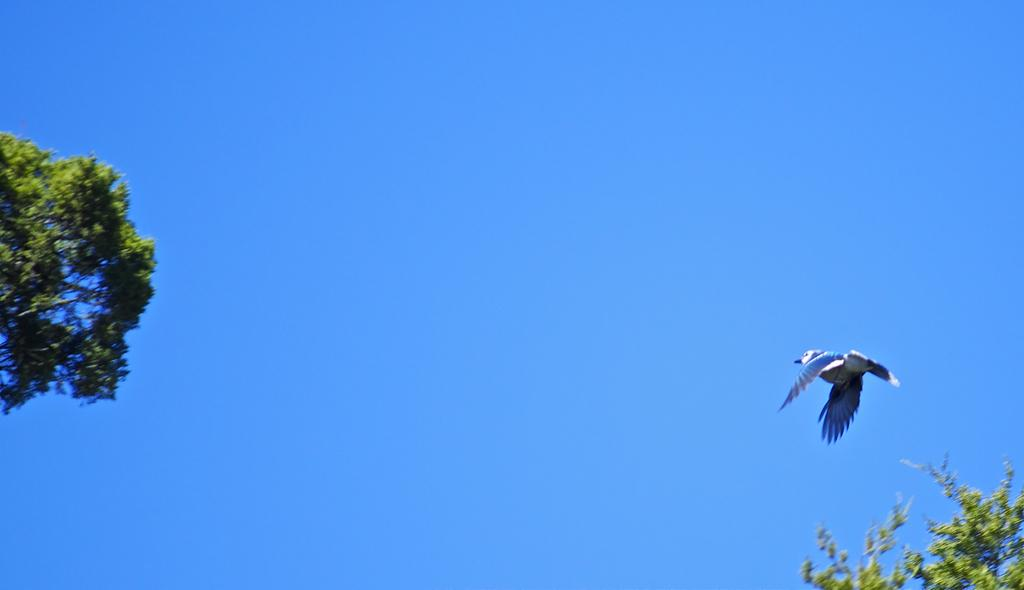What type of animal can be seen in the image? There is a bird in the image. What colors are present on the bird? The bird has blue, white, and black colors. What is the bird doing in the image? The bird is flying in the air. What type of vegetation is present in the image? There are trees in the image. What color are the trees? The trees are green in color. What can be seen in the background of the image? The sky is visible in the background of the image. What type of tin can be seen in the image? There is no tin present in the image. What color is the bird's underwear in the image? Birds do not wear underwear, so this question cannot be answered. 